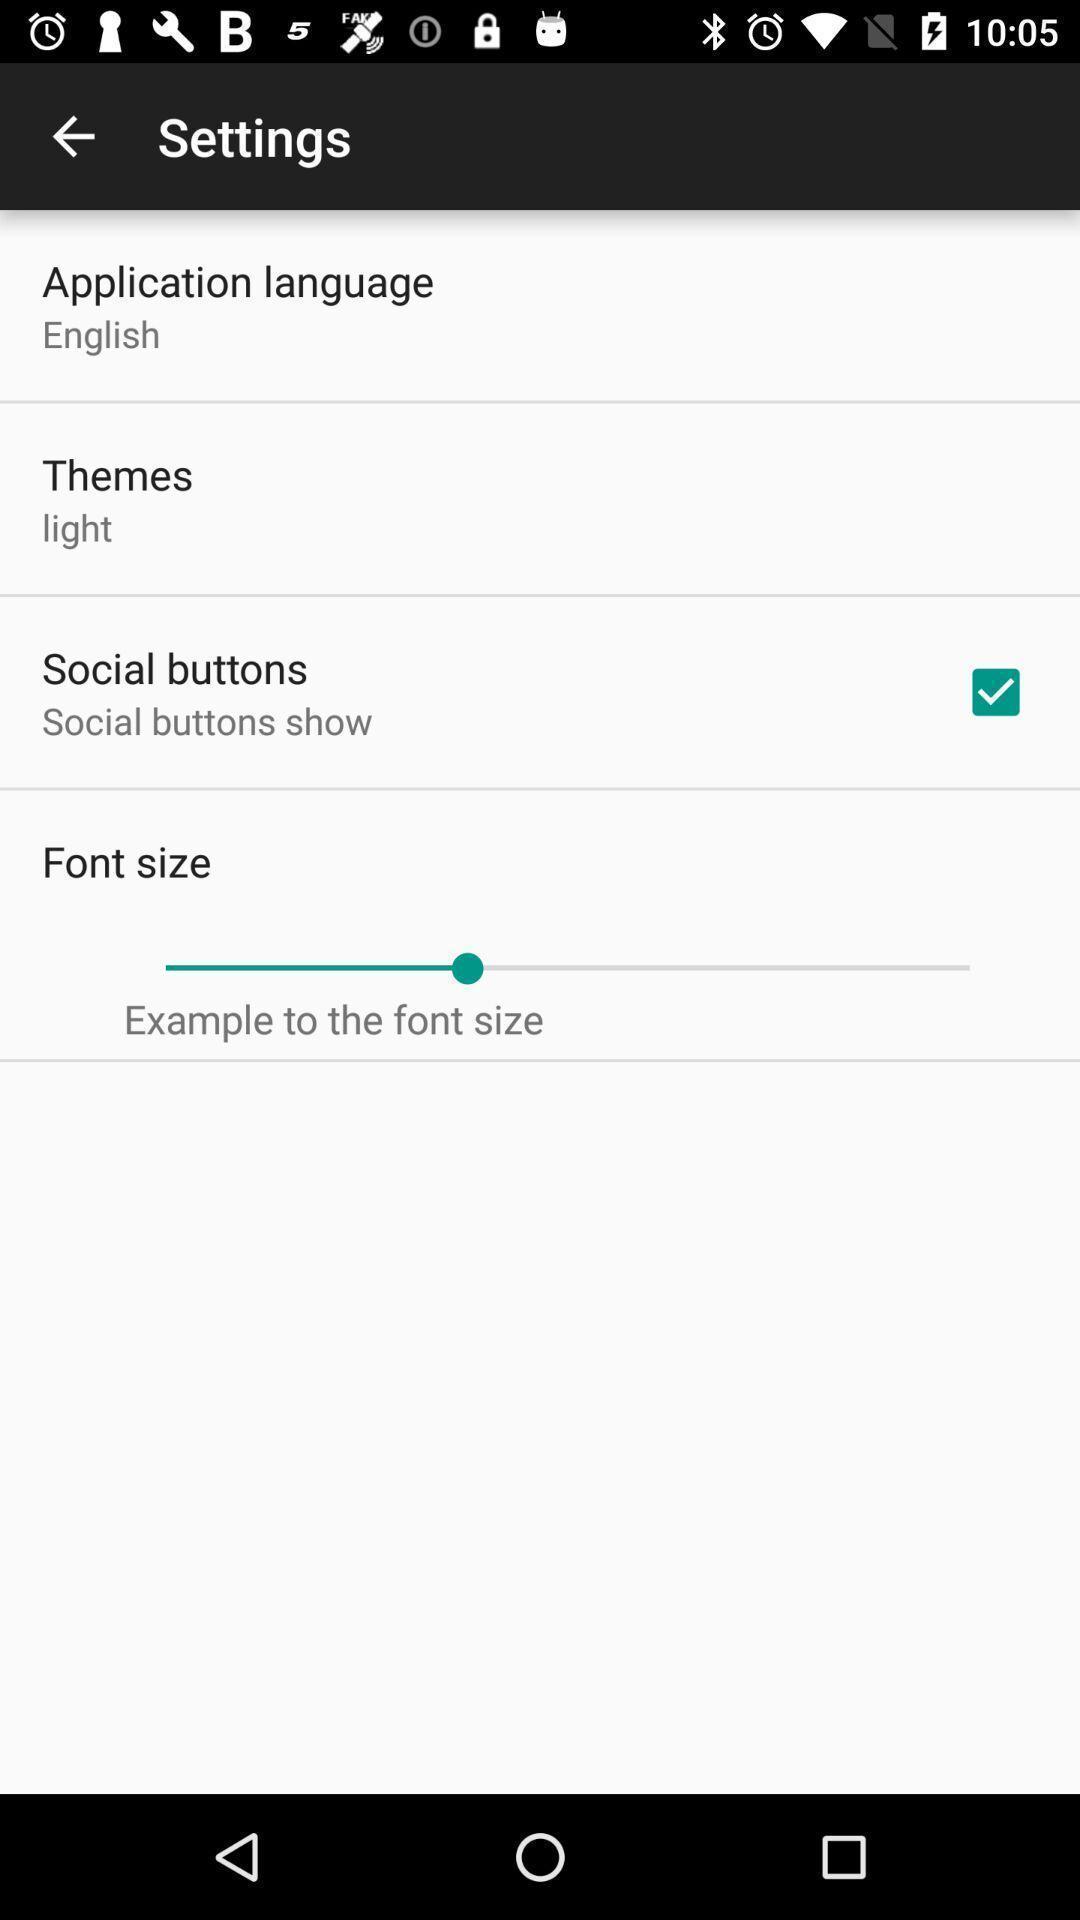Explain what's happening in this screen capture. Page displays different settings in app. 